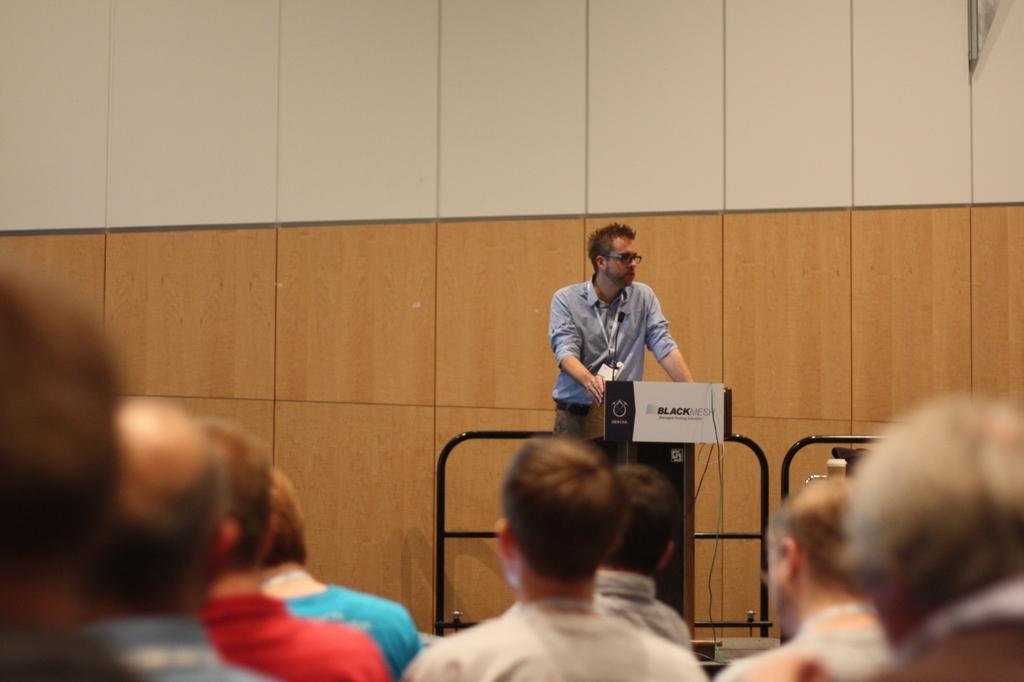How would you summarize this image in a sentence or two? There is a group of persons sitting at the bottom of this image and there is one person standing in middle is holding an object. There is a wall in the background. 